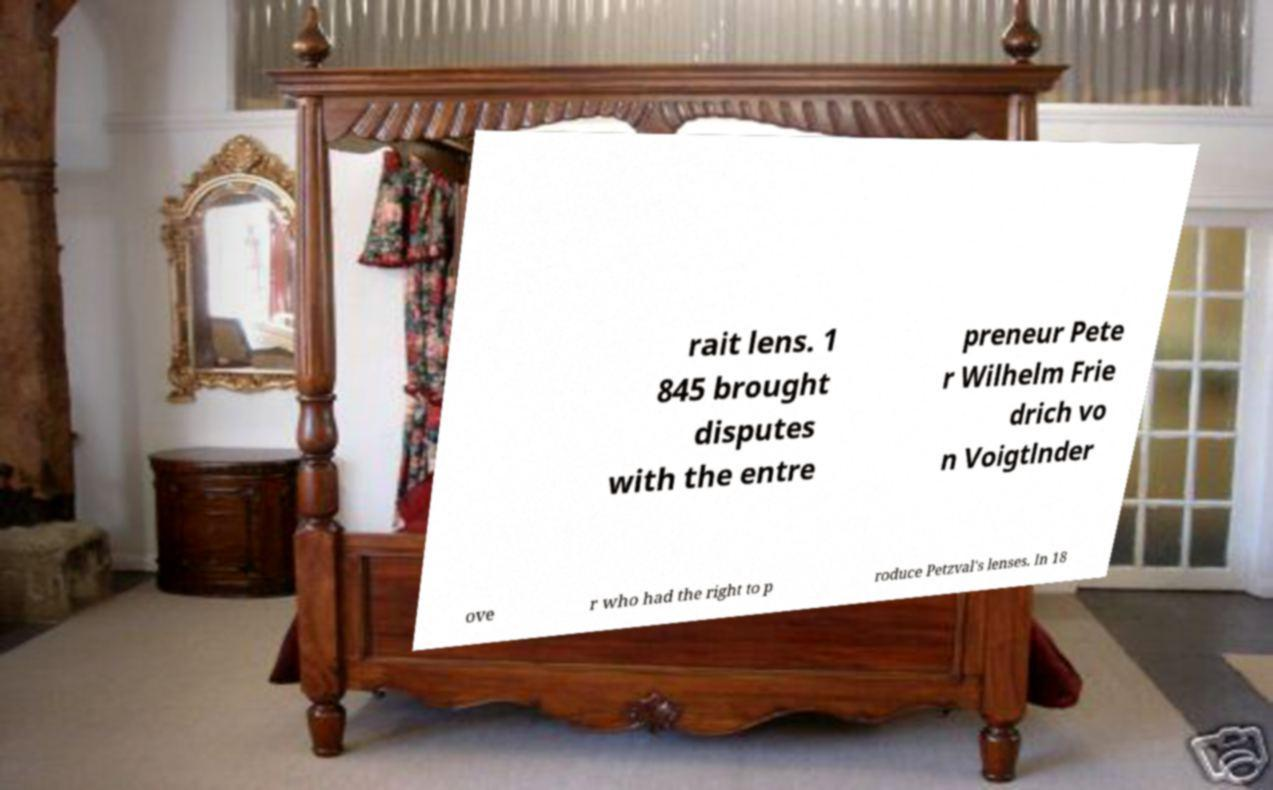Please read and relay the text visible in this image. What does it say? rait lens. 1 845 brought disputes with the entre preneur Pete r Wilhelm Frie drich vo n Voigtlnder ove r who had the right to p roduce Petzval's lenses. In 18 